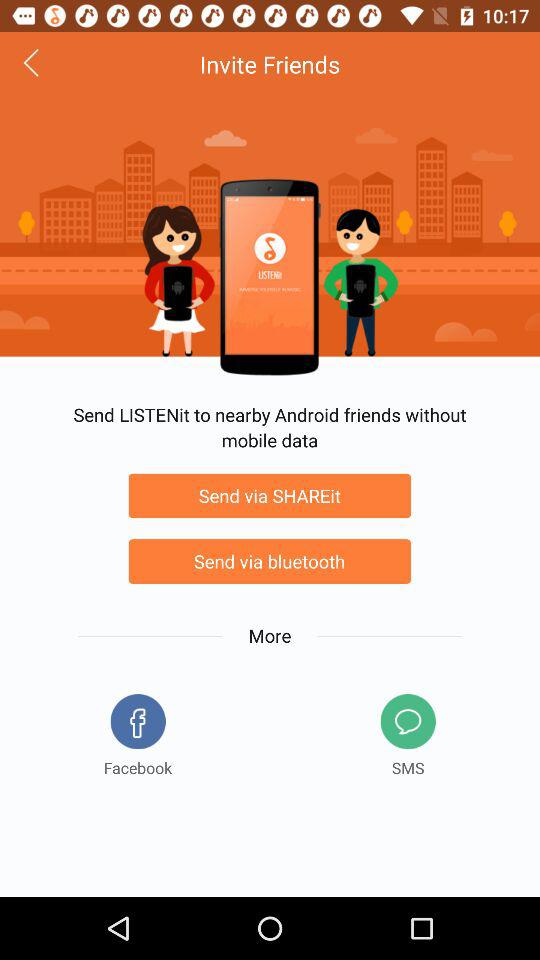How many friends have been invited?
When the provided information is insufficient, respond with <no answer>. <no answer> 